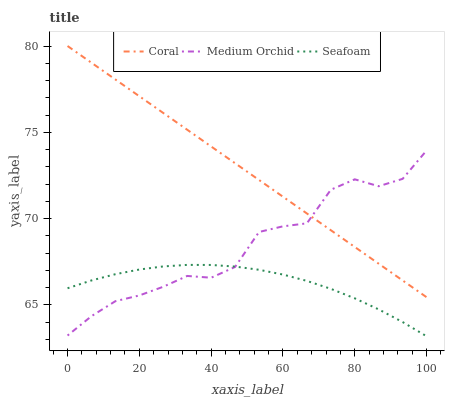Does Seafoam have the minimum area under the curve?
Answer yes or no. Yes. Does Coral have the maximum area under the curve?
Answer yes or no. Yes. Does Medium Orchid have the minimum area under the curve?
Answer yes or no. No. Does Medium Orchid have the maximum area under the curve?
Answer yes or no. No. Is Coral the smoothest?
Answer yes or no. Yes. Is Medium Orchid the roughest?
Answer yes or no. Yes. Is Seafoam the smoothest?
Answer yes or no. No. Is Seafoam the roughest?
Answer yes or no. No. Does Seafoam have the lowest value?
Answer yes or no. Yes. Does Medium Orchid have the lowest value?
Answer yes or no. No. Does Coral have the highest value?
Answer yes or no. Yes. Does Medium Orchid have the highest value?
Answer yes or no. No. Is Seafoam less than Coral?
Answer yes or no. Yes. Is Coral greater than Seafoam?
Answer yes or no. Yes. Does Medium Orchid intersect Coral?
Answer yes or no. Yes. Is Medium Orchid less than Coral?
Answer yes or no. No. Is Medium Orchid greater than Coral?
Answer yes or no. No. Does Seafoam intersect Coral?
Answer yes or no. No. 